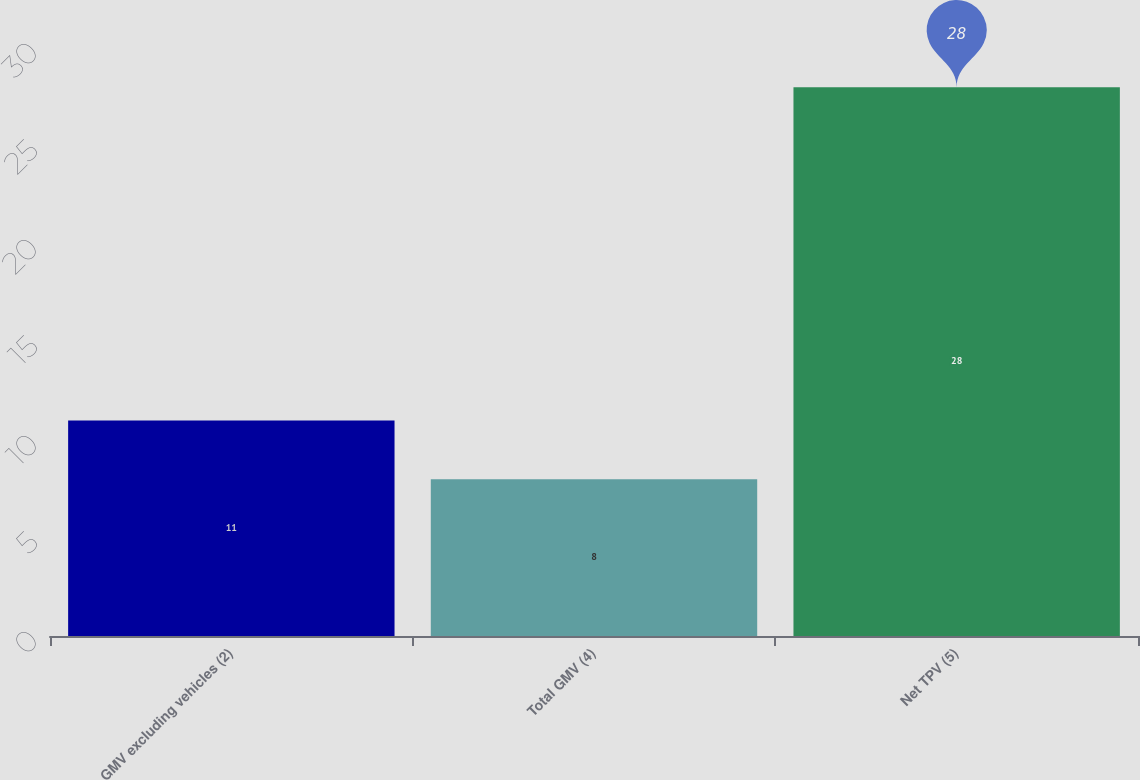<chart> <loc_0><loc_0><loc_500><loc_500><bar_chart><fcel>GMV excluding vehicles (2)<fcel>Total GMV (4)<fcel>Net TPV (5)<nl><fcel>11<fcel>8<fcel>28<nl></chart> 